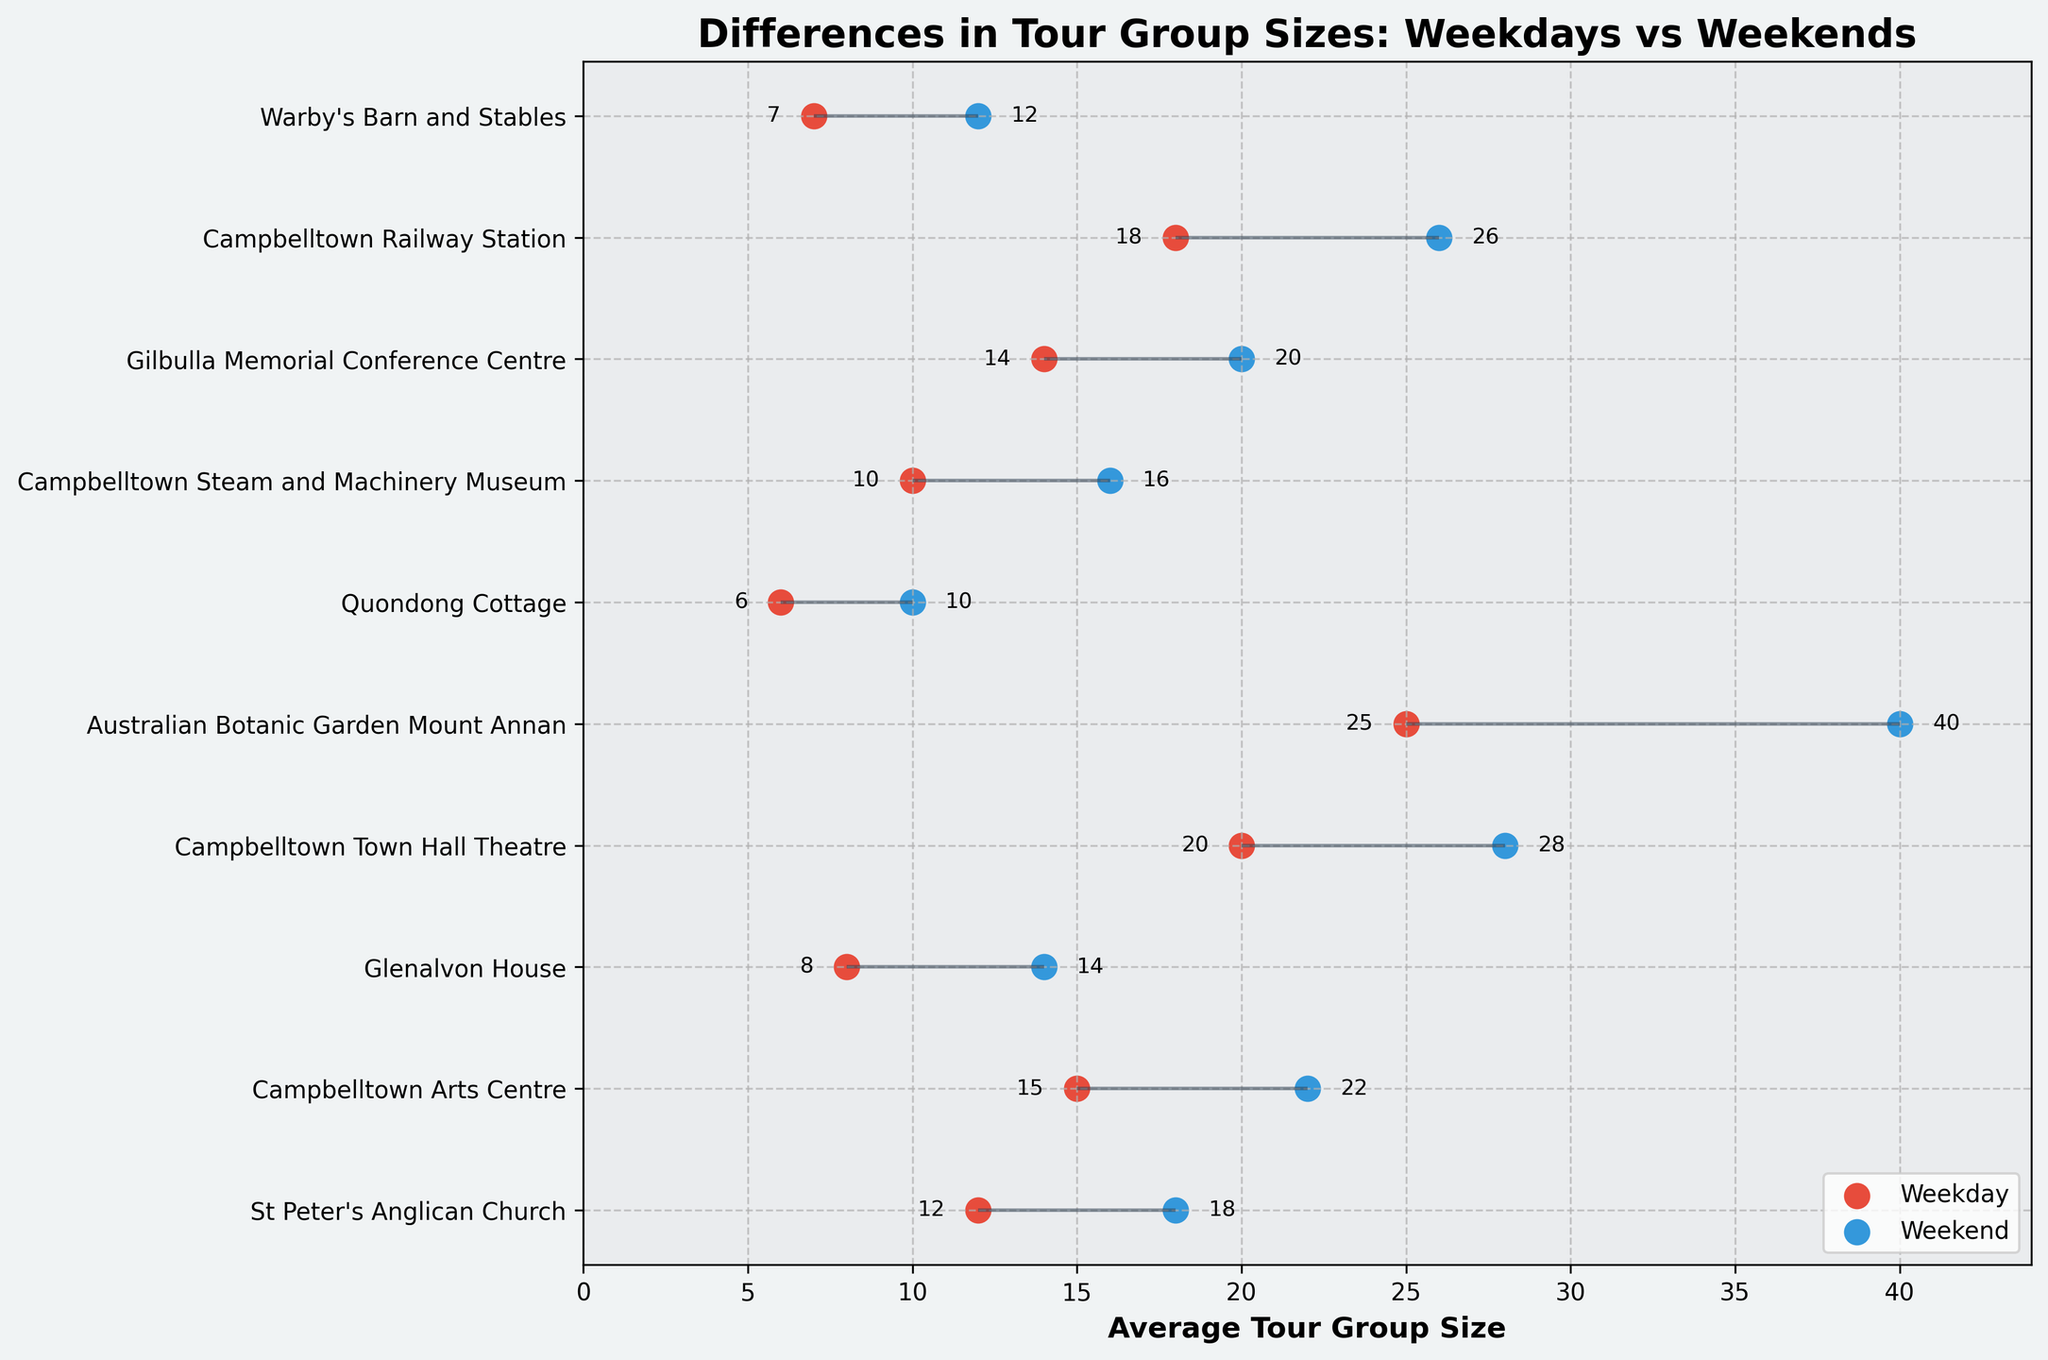What's the title of the plot? The title is prominently displayed at the top of the plot. Reading it directly will provide the answer.
Answer: Differences in Tour Group Sizes: Weekdays vs Weekends How many historical sites are compared in the figure? Count the y-ticks or the labels along the y-axis to find the total number of historical sites listed.
Answer: 10 Which historical site has the largest difference in average tour group sizes between weekdays and weekends? Identify the site with the longest line connecting the weekday and weekend points, which reflects the largest difference.
Answer: Australian Botanic Garden Mount Annan What's the average tour group size at Campbelltown Arts Centre on weekends? Locate the 'Campbelltown Arts Centre' label along the y-axis, and then check the corresponding weekend data point for its value.
Answer: 22 Which site has the smallest weekday average tour group size? Compare the weekday average sizes for each site and identify the smallest value.
Answer: Quondong Cottage What is the sum of the weekday and weekend average tour group sizes for Campbelltown Railway Station? Add the weekday average (18) and the weekend average (26) for Campbelltown Railway Station.
Answer: 44 Is the average tour group size at Warby's Barn and Stables larger on weekends than on weekdays? Compare the weekday and weekend average sizes for Warby's Barn and Stables and check if the weekend number is larger.
Answer: Yes How many sites have a weekend average tour group size greater than 20? Count the number of sites where the weekend average tour group size is more than 20 by looking at the weekend data points for each site.
Answer: 4 Which has a higher average increase from weekday to weekend tour group sizes, Quondong Cottage or Glenalvon House? Calculate the increase for each site: Quondong Cottage (10 - 6 = 4), Glenalvon House (14 - 8 = 6). Compare the increases to identify which is higher.
Answer: Glenalvon House Compare the average tour group sizes on weekdays between St Peter's Anglican Church and Campbelltown Town Hall Theatre. Which one is higher? Look at the weekday average sizes for both sites and compare their values: St Peter's Anglican Church (12) and Campbelltown Town Hall Theatre (20).
Answer: Campbelltown Town Hall Theatre 